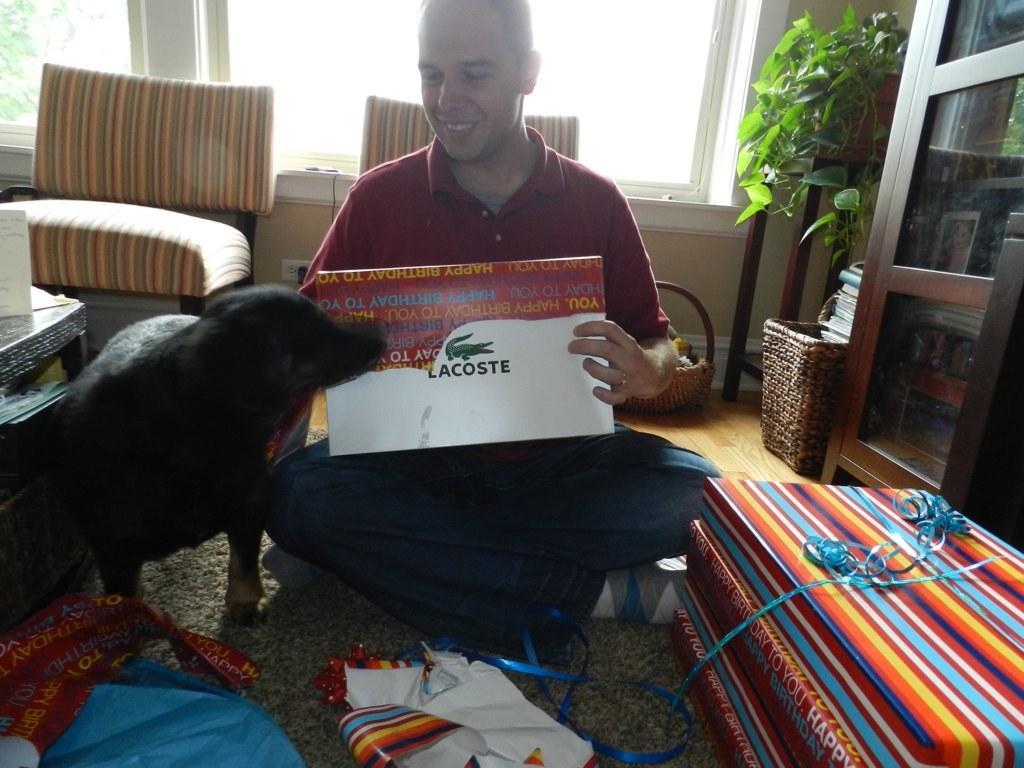Describe this image in one or two sentences. A man is sitting and opening gift packs. There is a dog beside him. There are table,gift packs,two sofa chairs,house plat and cup boards around him. 